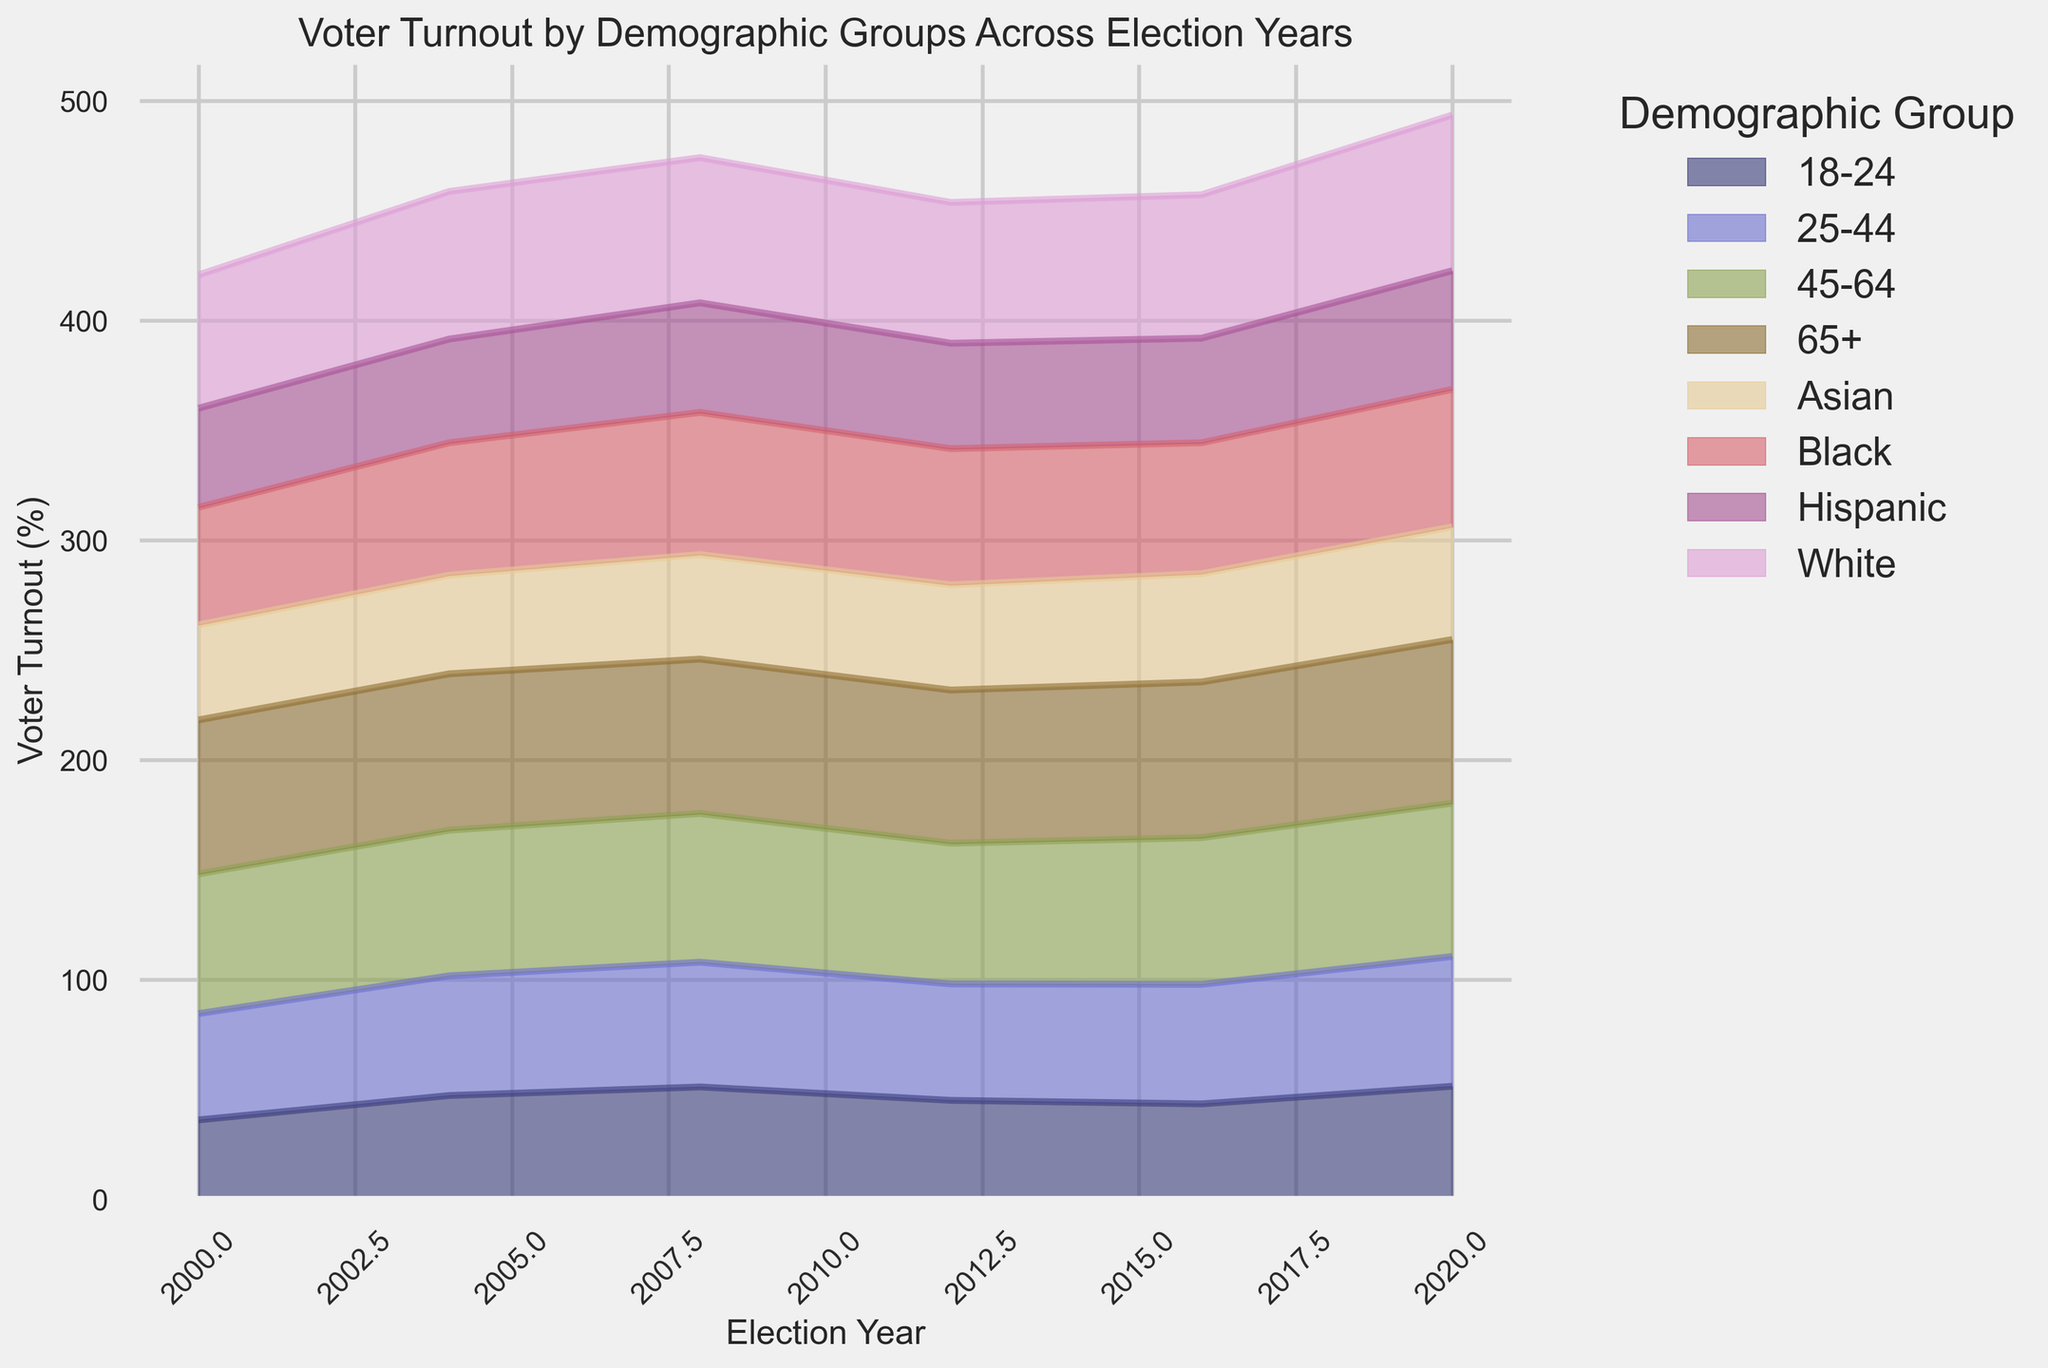Which demographic group has the highest voter turnout in 2020? To determine the group with the highest voter turnout in 2020, locate the 2020 election year on the x-axis and identify the tallest segment in the area chart. The "65+" group has the highest voter turnout.
Answer: 65+ Which demographic group had the largest increase in voter turnout between 2016 and 2020? Look at the voter turnout percentages for 2016 and 2020 for each demographic group and calculate the differences. The "18-24" group had an increase from 43.4% in 2016 to 51.4% in 2020, which is the largest increase of 8%.
Answer: 18-24 What is the average voter turnout for the "Black" demographic across the years shown? Sum the voter turnout percentages for the "Black" demographic for each election year (53.5, 60.3, 64.7, 62.0, 59.6, 62.6). Then, divide by the number of election years (6). The total sum is 362.7, and the average is 362.7/6 = 60.45%.
Answer: 60.45% Which year saw the lowest voter turnout for the "18-24" demographic? Identify the voter turnout percentages for the "18-24" demographic across all election years. The year 2000 has the lowest, with a turnout of 36.1%.
Answer: 2000 By how much did the turnout for the "Hispanic" demographic change from 2000 to 2020? Subtract the voter turnout percentage for the "Hispanic" group in 2000 (45.1%) from the 2020 percentage (54.0%). The change is 54.0% - 45.1% = 8.9%.
Answer: 8.9% Which demographic groups had a higher voter turnout than the "White" group in any of the election years? Compare the voter turnout percentages of the "White" group to other groups across all election years. The "65+" group consistently had a higher voter turnout than the "White" group in all election years. The "Black" group had a higher turnout in 2008.
Answer: 65+, Black (2008) What is the difference in turnout between "25-44" and "45-64" demographics in the 2020 election? Find the voter turnout percentages for "25-44" (59.1%) and "45-64" (69.8%) in the 2020 election. The difference is 69.8% - 59.1% = 10.7%.
Answer: 10.7% In which election year did the "Asian" demographic see the most significant increase in voter turnout? Calculate the year-over-year changes for the "Asian" demographic. The largest increase is between 2016 (49.3%) and 2020 (51.3%), which is 2%.
Answer: 2020 